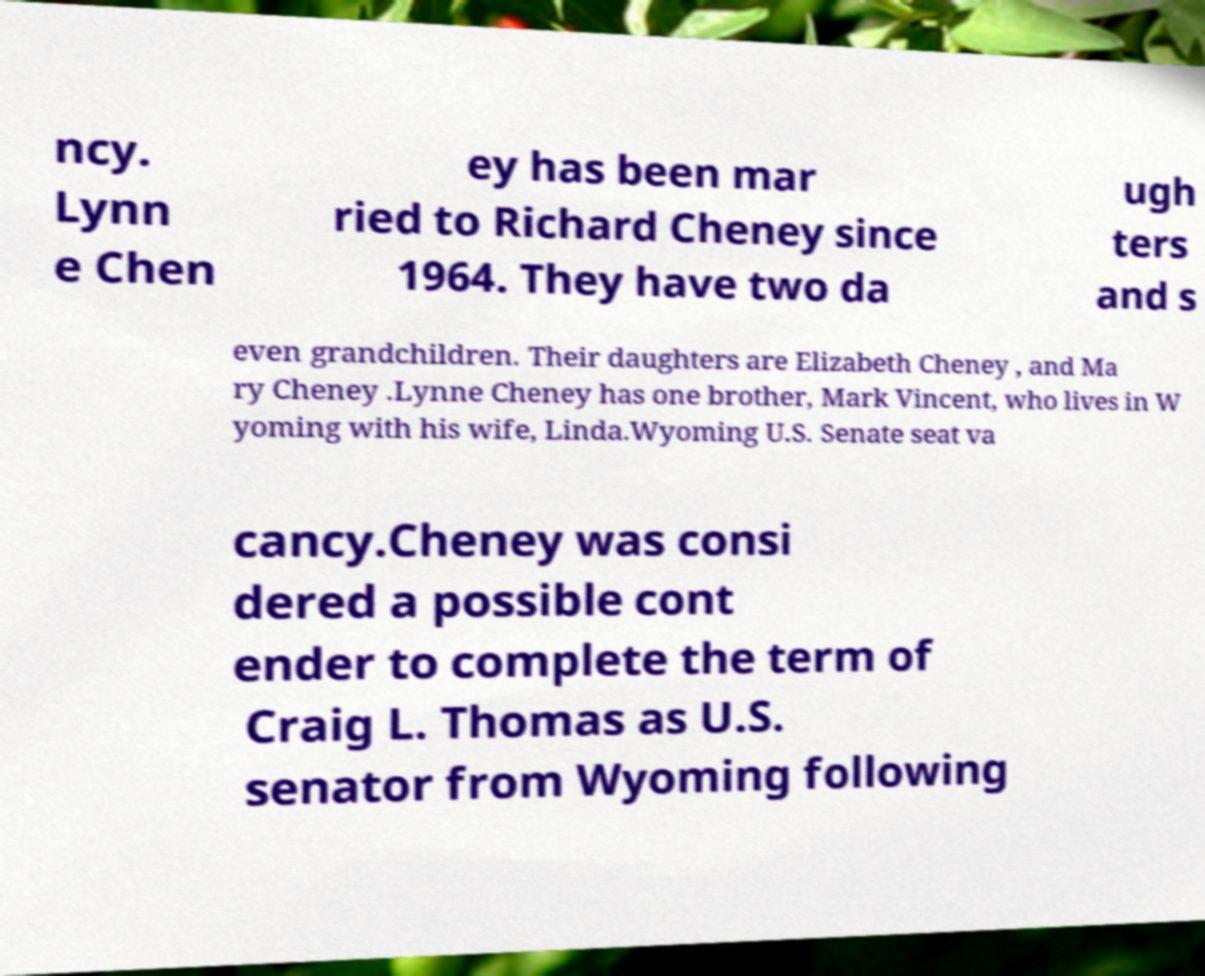What messages or text are displayed in this image? I need them in a readable, typed format. ncy. Lynn e Chen ey has been mar ried to Richard Cheney since 1964. They have two da ugh ters and s even grandchildren. Their daughters are Elizabeth Cheney , and Ma ry Cheney .Lynne Cheney has one brother, Mark Vincent, who lives in W yoming with his wife, Linda.Wyoming U.S. Senate seat va cancy.Cheney was consi dered a possible cont ender to complete the term of Craig L. Thomas as U.S. senator from Wyoming following 